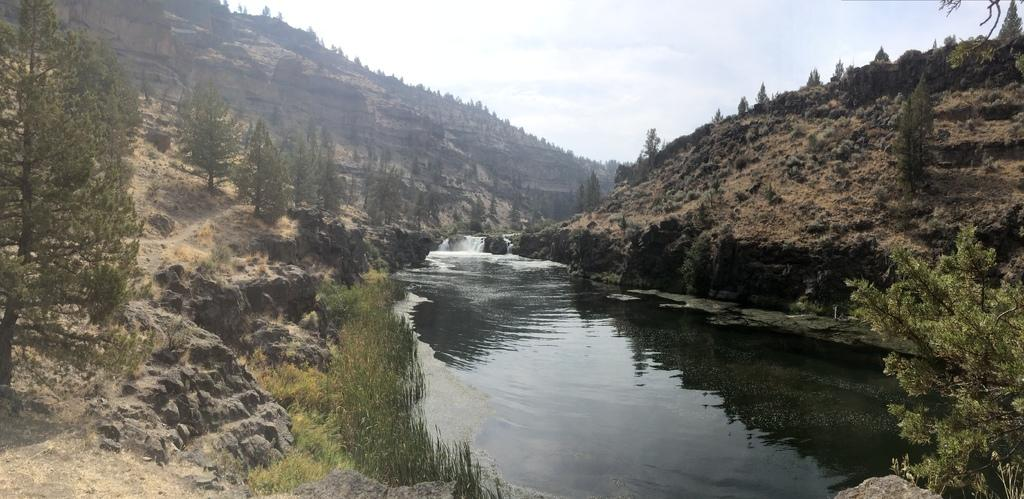What type of vegetation can be seen in the image? There are trees in the image. What natural element is visible in the image besides the trees? There is water visible in the image. What type of ground cover is present in the image? There is grass in the image. What geological feature can be seen in the distance? There are mountains in the image. What part of the natural environment is visible in the background of the image? The sky is visible in the background of the image. What type of wool can be seen on the stove in the image? There is no stove or wool present in the image. How does the wool smash the trees in the image? There is no wool or smashing of trees in the image; the trees are standing upright. 